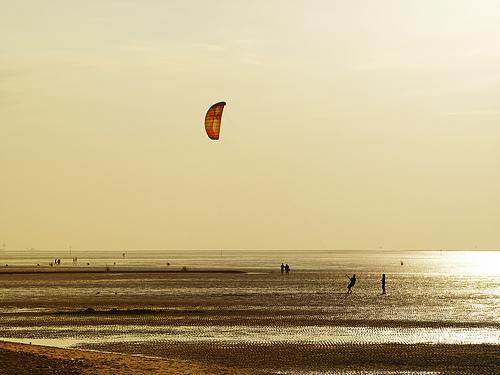Question: what color is the kite?
Choices:
A. A mix of green, blue, and brown.
B. A mix of red, yellow, and orange.
C. A mix of black, white, and brown.
D. A mix of pink, white, and purple.
Answer with the letter. Answer: B Question: where is this place?
Choices:
A. At a church.
B. At a business office.
C. At a meeting hall.
D. At the beach.
Answer with the letter. Answer: D Question: how is the kite being flown?
Choices:
A. With an engine.
B. With a long string and good wind.
C. With a windmill.
D. With a powered fan.
Answer with the letter. Answer: B 